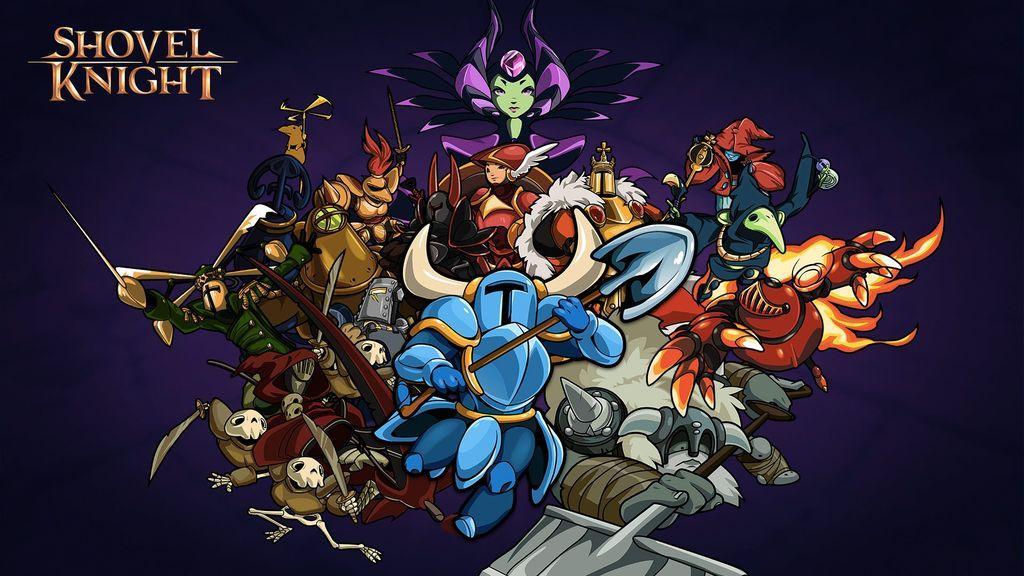Please provide a concise description of this image. Here in this picture we can see a poster of an cartoon program and in this we can see number of cartoon characters and on the left top side we can see some text present. 